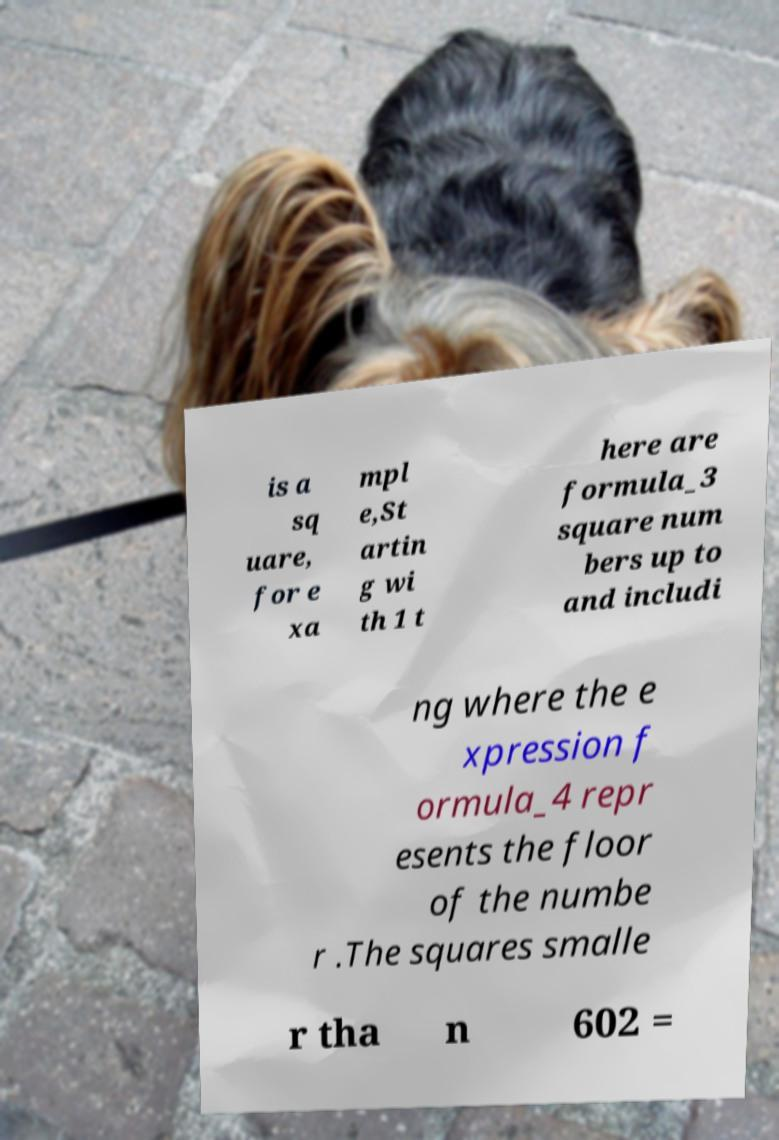I need the written content from this picture converted into text. Can you do that? is a sq uare, for e xa mpl e,St artin g wi th 1 t here are formula_3 square num bers up to and includi ng where the e xpression f ormula_4 repr esents the floor of the numbe r .The squares smalle r tha n 602 = 